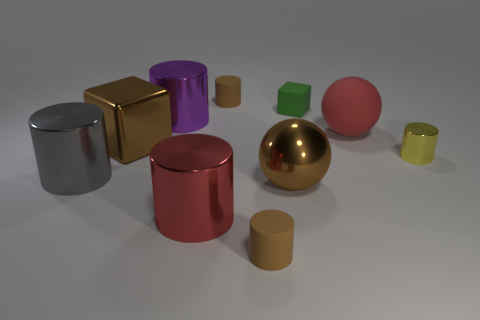Subtract all red metallic cylinders. How many cylinders are left? 5 Subtract all brown spheres. How many brown cylinders are left? 2 Subtract all purple cylinders. How many cylinders are left? 5 Subtract all cylinders. How many objects are left? 4 Add 8 large gray things. How many large gray things are left? 9 Add 7 small gray metal spheres. How many small gray metal spheres exist? 7 Subtract 0 purple blocks. How many objects are left? 10 Subtract all brown spheres. Subtract all cyan cubes. How many spheres are left? 1 Subtract all large gray cylinders. Subtract all purple rubber cylinders. How many objects are left? 9 